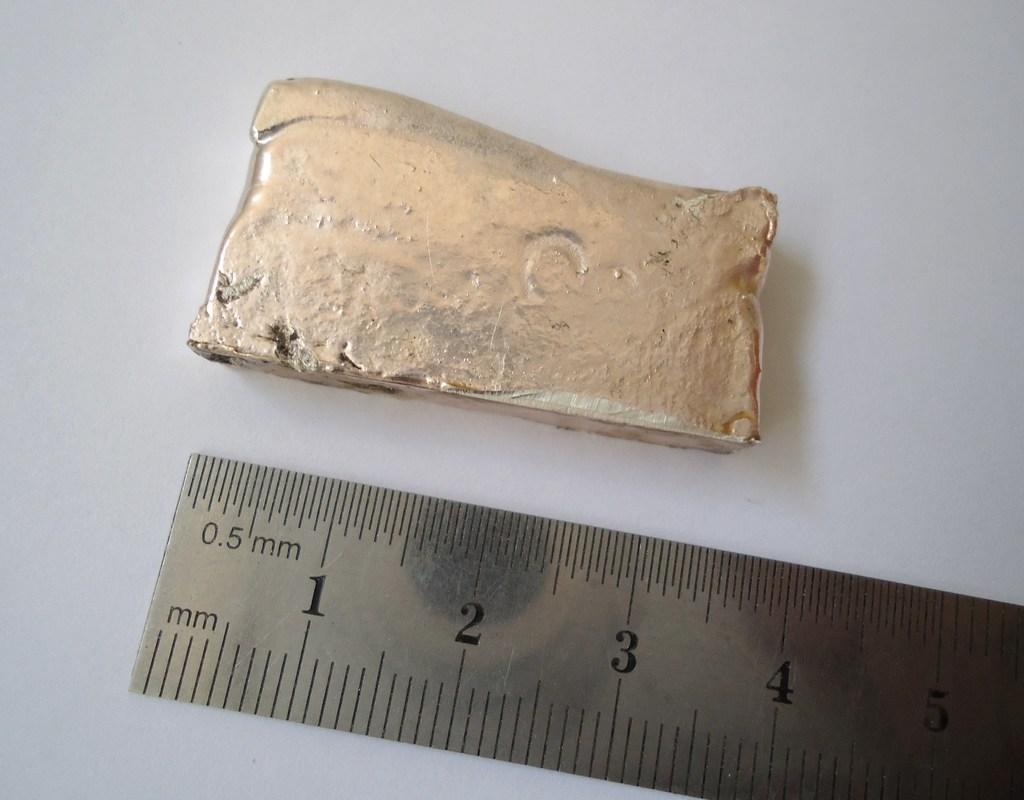Are these actual numbers?
Ensure brevity in your answer.  Yes. What unit of measurement is labeled?
Offer a very short reply. Mm. 